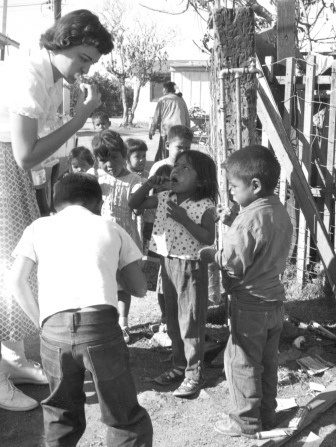Describe the objects in this image and their specific colors. I can see people in white, gray, darkgray, and black tones, people in white, gray, black, darkgray, and lightgray tones, people in white, gray, black, darkgray, and lightgray tones, people in white, gray, darkgray, and black tones, and people in white, darkgray, gray, lightgray, and black tones in this image. 